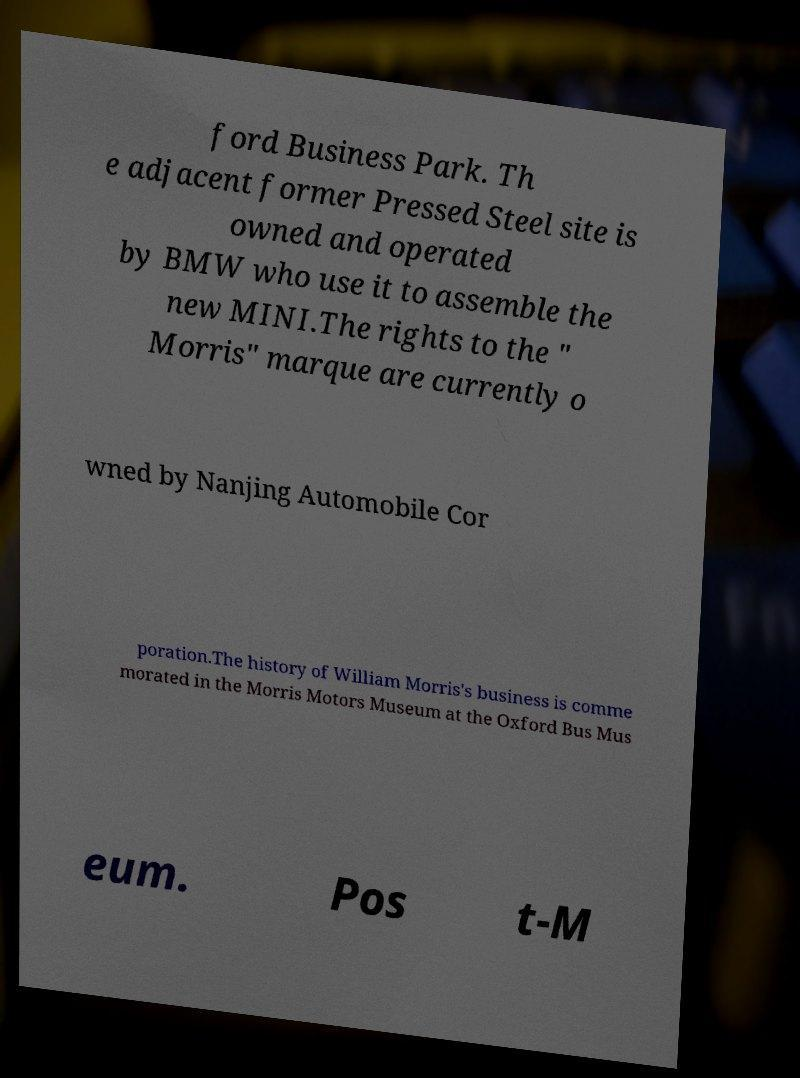What messages or text are displayed in this image? I need them in a readable, typed format. ford Business Park. Th e adjacent former Pressed Steel site is owned and operated by BMW who use it to assemble the new MINI.The rights to the " Morris" marque are currently o wned by Nanjing Automobile Cor poration.The history of William Morris's business is comme morated in the Morris Motors Museum at the Oxford Bus Mus eum. Pos t-M 